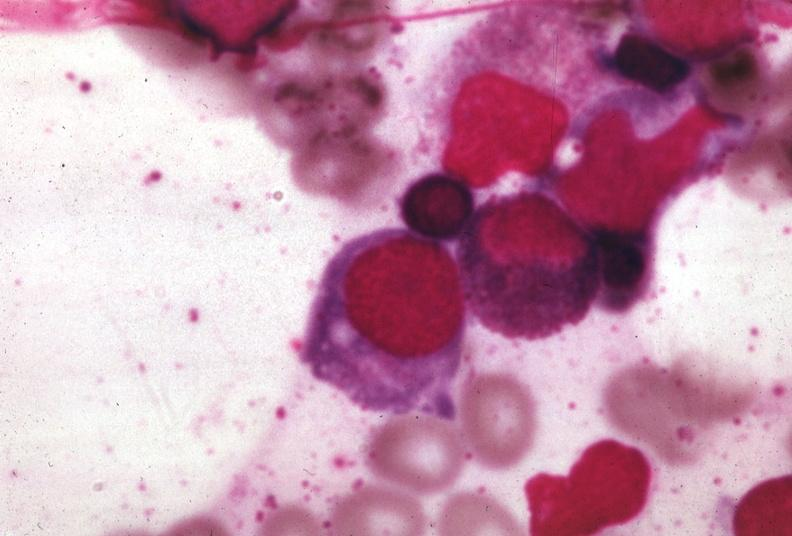does choanal atresia show wrights?
Answer the question using a single word or phrase. No 